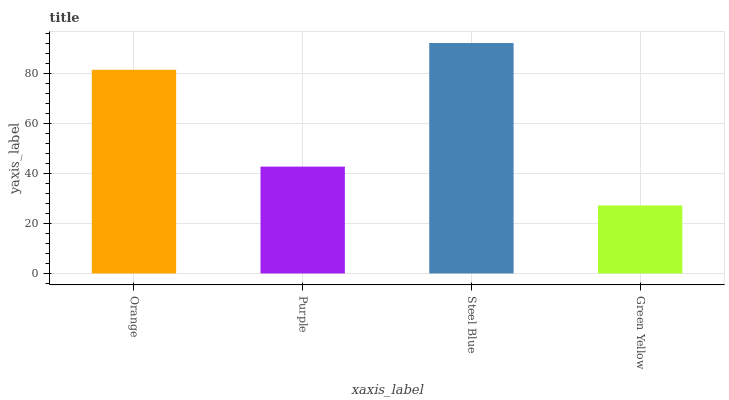Is Green Yellow the minimum?
Answer yes or no. Yes. Is Steel Blue the maximum?
Answer yes or no. Yes. Is Purple the minimum?
Answer yes or no. No. Is Purple the maximum?
Answer yes or no. No. Is Orange greater than Purple?
Answer yes or no. Yes. Is Purple less than Orange?
Answer yes or no. Yes. Is Purple greater than Orange?
Answer yes or no. No. Is Orange less than Purple?
Answer yes or no. No. Is Orange the high median?
Answer yes or no. Yes. Is Purple the low median?
Answer yes or no. Yes. Is Green Yellow the high median?
Answer yes or no. No. Is Orange the low median?
Answer yes or no. No. 